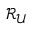Convert formula to latex. <formula><loc_0><loc_0><loc_500><loc_500>\mathcal { R } _ { \mathcal { U } }</formula> 